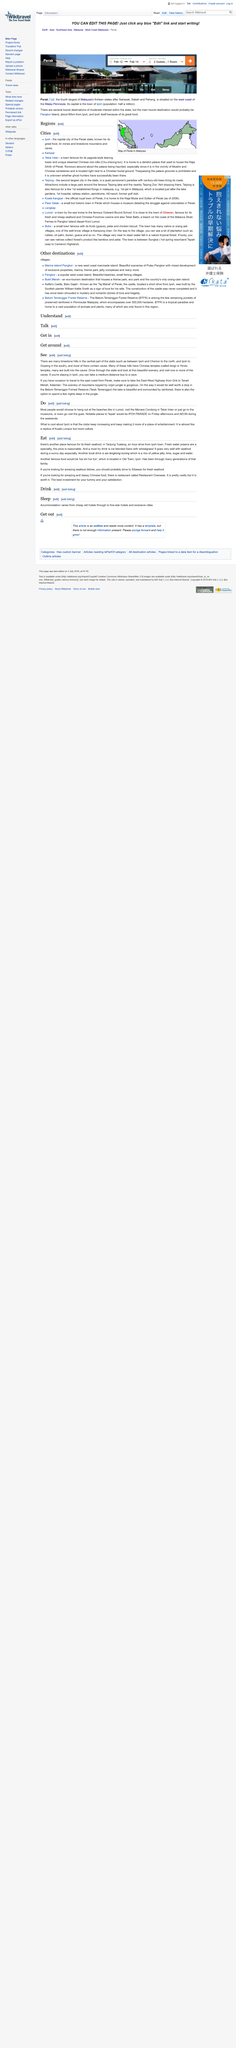Point out several critical features in this image. Yes, many of the temples are built into the caves. The IPOH PARADE is a notable place to 'lepak' in Ipoh, as it is a popular spot for residents and tourists to relax and socialize. The majority of people choose to spend their time at the beaches in Ipoh. The jelly mentioned in the article is yellow. The Chinese temples are called "tong. 